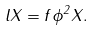<formula> <loc_0><loc_0><loc_500><loc_500>l X = f \phi ^ { 2 } X .</formula> 